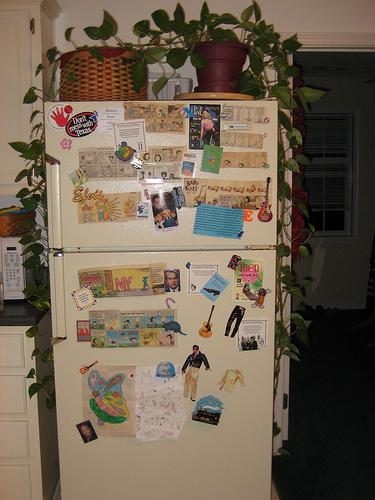Mention the presence of any kitchen appliances in the image. There is a white microwave on the counter and a cream-colored refrigerator in the image. Briefly describe the color scheme of the appliances and furniture in the image. The refrigerator is cream-colored, the microwave and cabinet are white, and there's a beige-colored window in the background. Enumerate the types of plants found in the image. There's a leafy green houseplant, a houseplant in a wicker basket, and a long potted plant on top of the fridge. Enumerate the different types of magnets on the refrigerator. There's a yellow guitar, an oval "Don't Mess with Texas," a brown guitar, and an Elvis magnet on the refrigerator. Describe the baskets found in the image in terms of content or location. A small wicker basket holds one houseplant, and another basket with markers is atop the microwave. In the image, which kitchen appliance has controls visible in the frame? The controls of a white microwave oven are visible in the image. What are the colors of the flower pots on top of the refrigerator? There's a brown and a maroon flower pot on top of the fridge. Mention some notable pieces of artwork present on the refrigerator. There's a newspaper comic strip, a picture of a colorful butterfly, and a coloring book page of a butterfly on the fridge. Provide a general description of the dominant objects in the image. A cream-colored refrigerator covered with magnets, comics, and artwork is located next to a white microwave and cabinet with drawers. Plants are atop the fridge. Discuss the placement of the plants in the image. The plants are placed on top of the refrigerator and one houseplant is inside a wicker basket. 